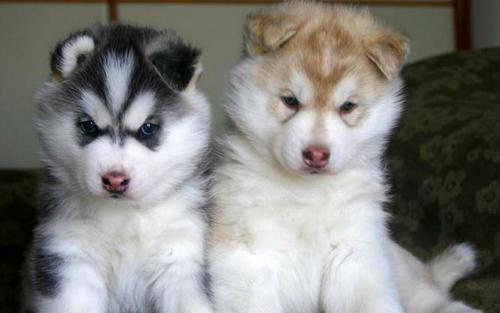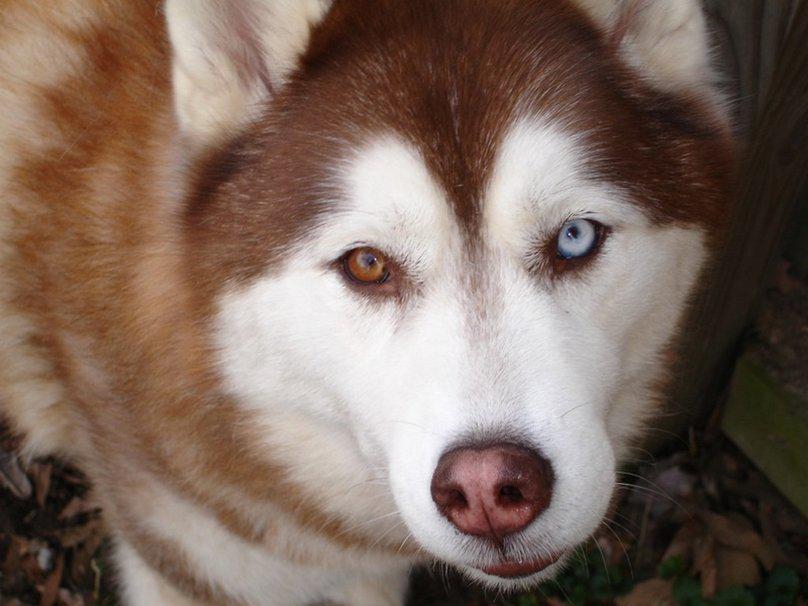The first image is the image on the left, the second image is the image on the right. Examine the images to the left and right. Is the description "There are two Huskies in one image and a single Husky in another image." accurate? Answer yes or no. Yes. The first image is the image on the left, the second image is the image on the right. Given the left and right images, does the statement "The left image contains two side-by-side puppies who are facing forward and sitting upright." hold true? Answer yes or no. Yes. 